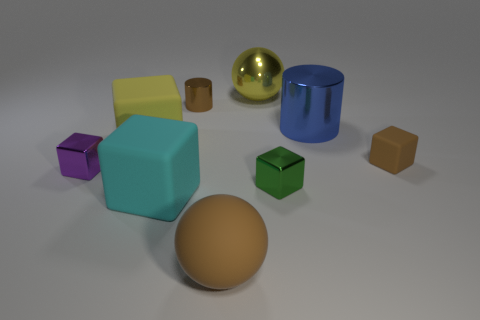Subtract all brown blocks. How many blocks are left? 4 Subtract all green blocks. How many blocks are left? 4 Subtract all yellow blocks. Subtract all gray cylinders. How many blocks are left? 4 Add 1 big yellow matte cubes. How many objects exist? 10 Subtract all blocks. How many objects are left? 4 Subtract 0 cyan spheres. How many objects are left? 9 Subtract all big matte objects. Subtract all brown cylinders. How many objects are left? 5 Add 9 tiny purple shiny cubes. How many tiny purple shiny cubes are left? 10 Add 4 small green metal things. How many small green metal things exist? 5 